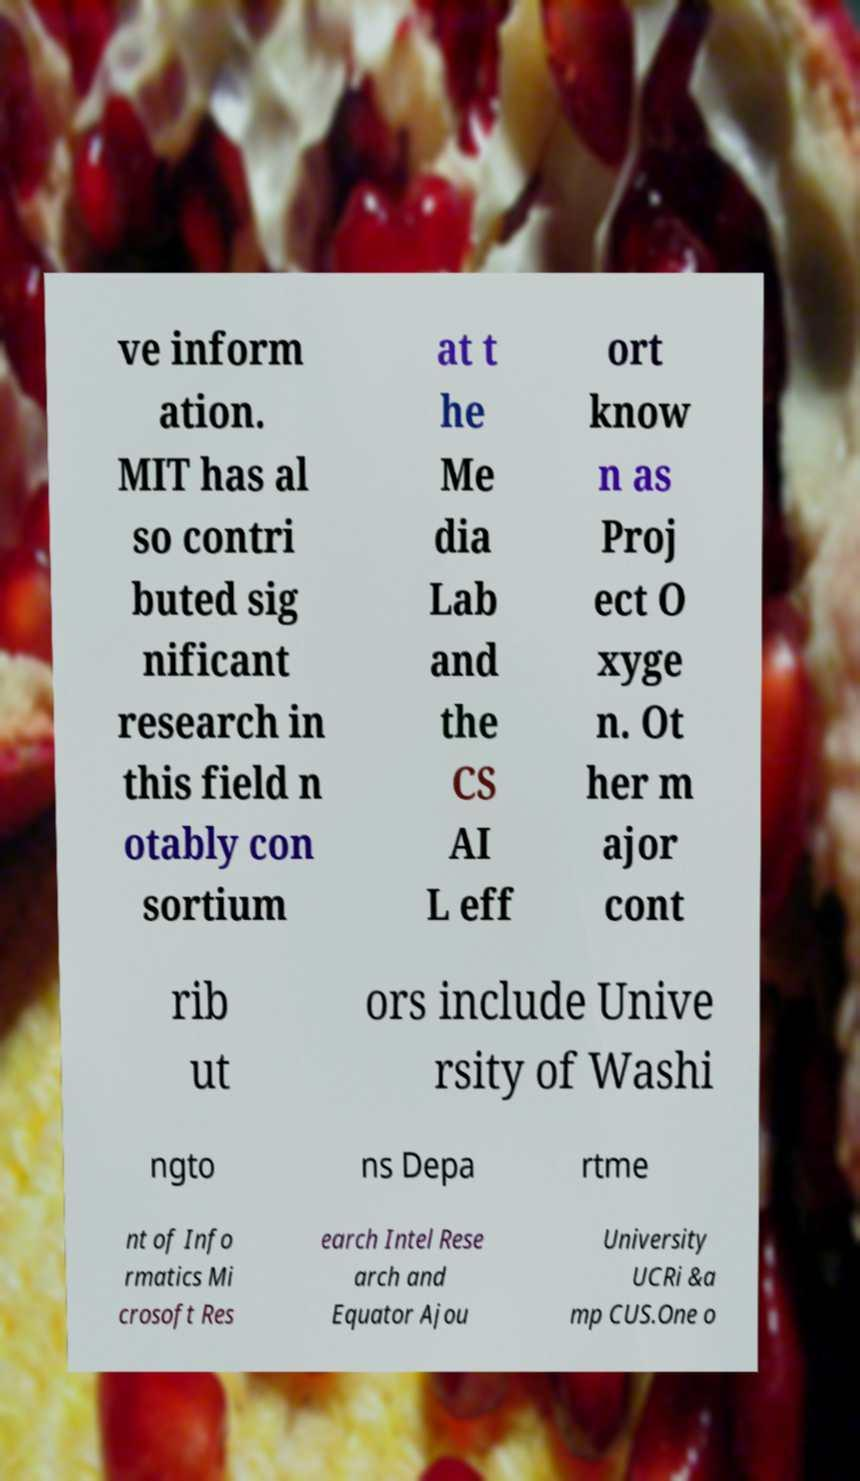I need the written content from this picture converted into text. Can you do that? ve inform ation. MIT has al so contri buted sig nificant research in this field n otably con sortium at t he Me dia Lab and the CS AI L eff ort know n as Proj ect O xyge n. Ot her m ajor cont rib ut ors include Unive rsity of Washi ngto ns Depa rtme nt of Info rmatics Mi crosoft Res earch Intel Rese arch and Equator Ajou University UCRi &a mp CUS.One o 